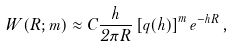<formula> <loc_0><loc_0><loc_500><loc_500>W ( { R } ; m ) \approx C \frac { h } { 2 \pi R } \left [ q ( h ) \right ] ^ { m } e ^ { - h R } \, ,</formula> 